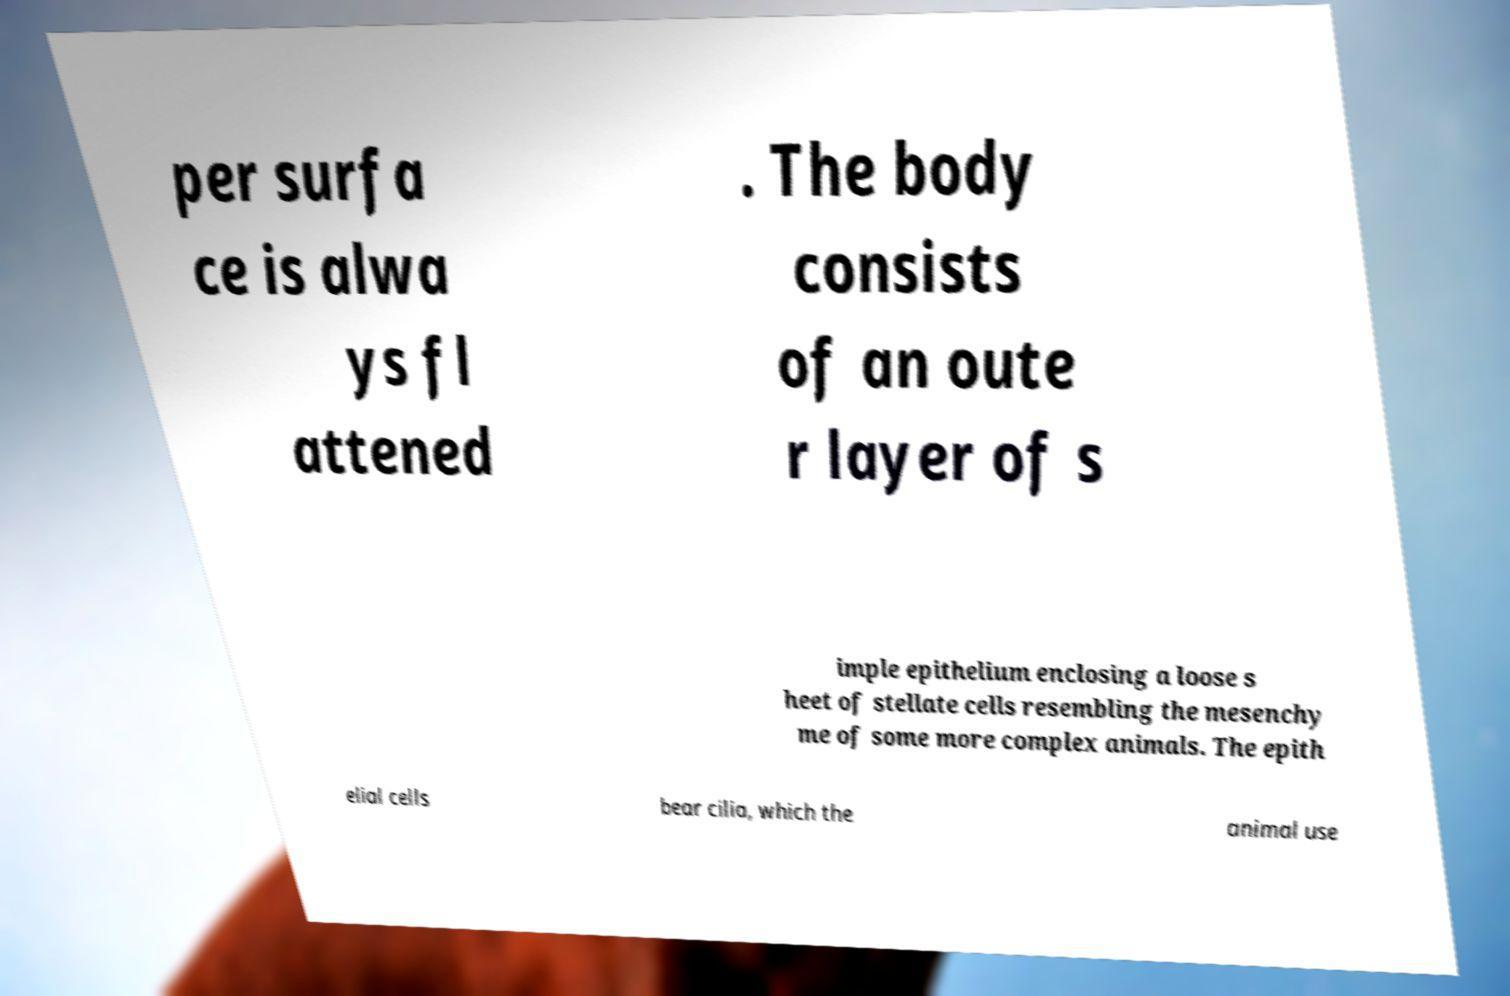There's text embedded in this image that I need extracted. Can you transcribe it verbatim? per surfa ce is alwa ys fl attened . The body consists of an oute r layer of s imple epithelium enclosing a loose s heet of stellate cells resembling the mesenchy me of some more complex animals. The epith elial cells bear cilia, which the animal use 